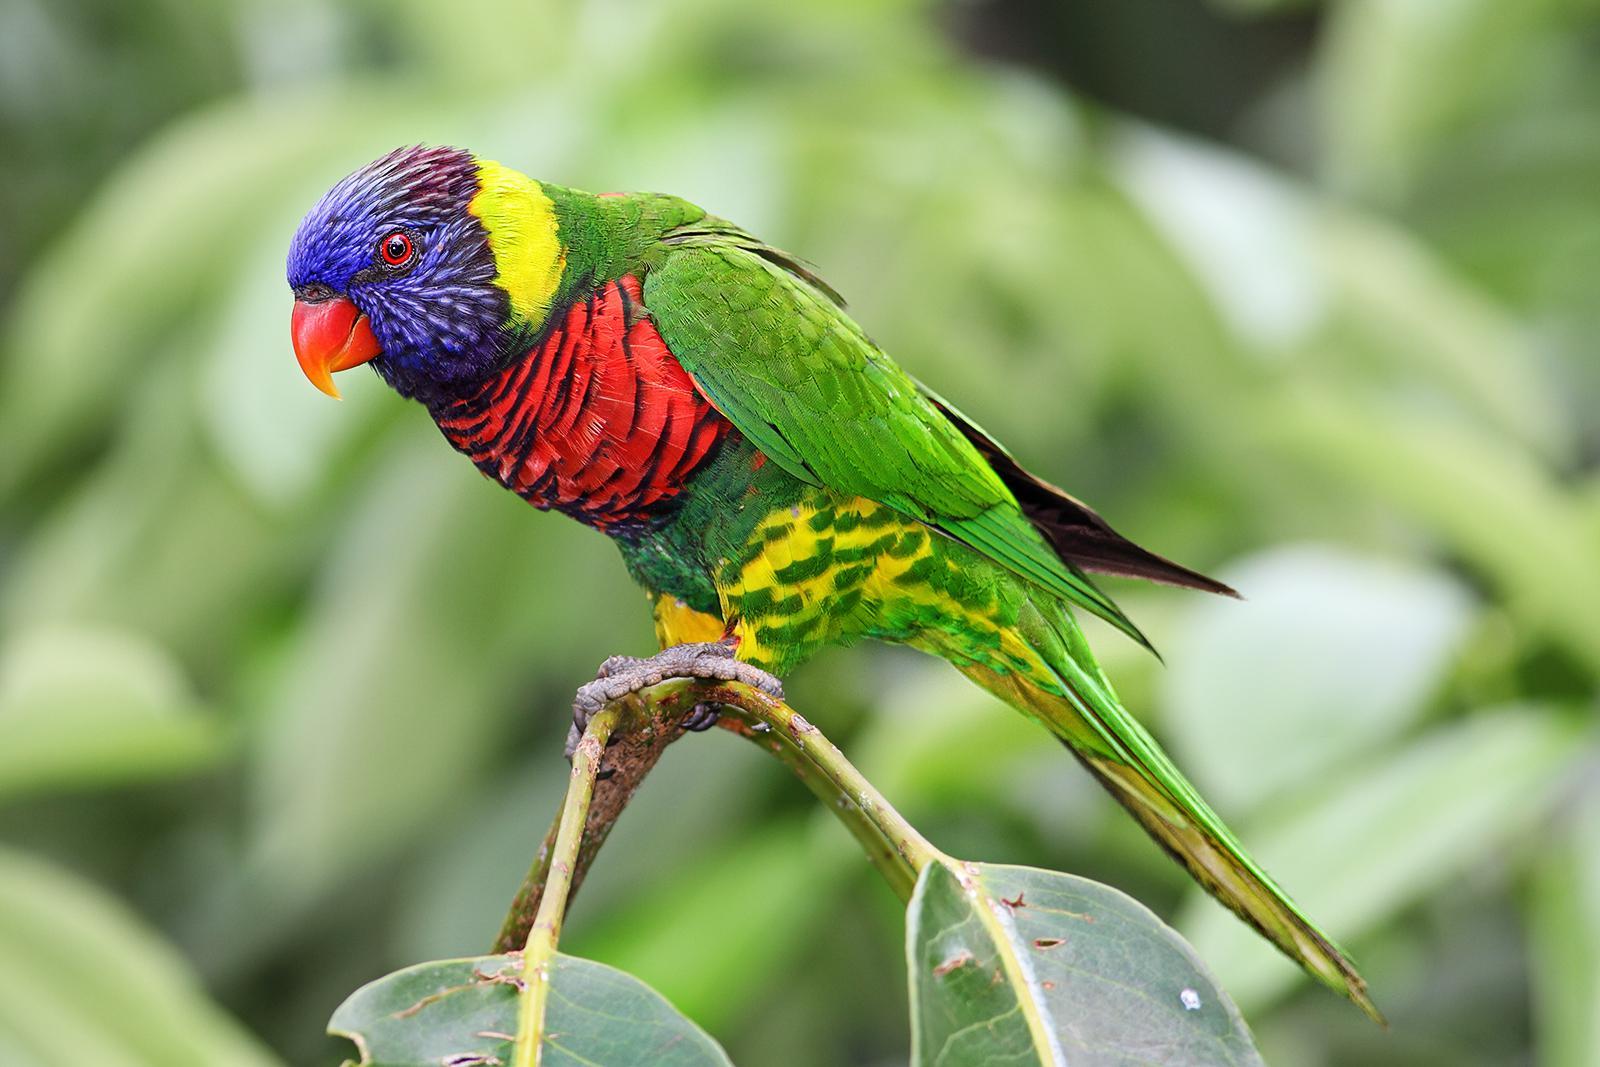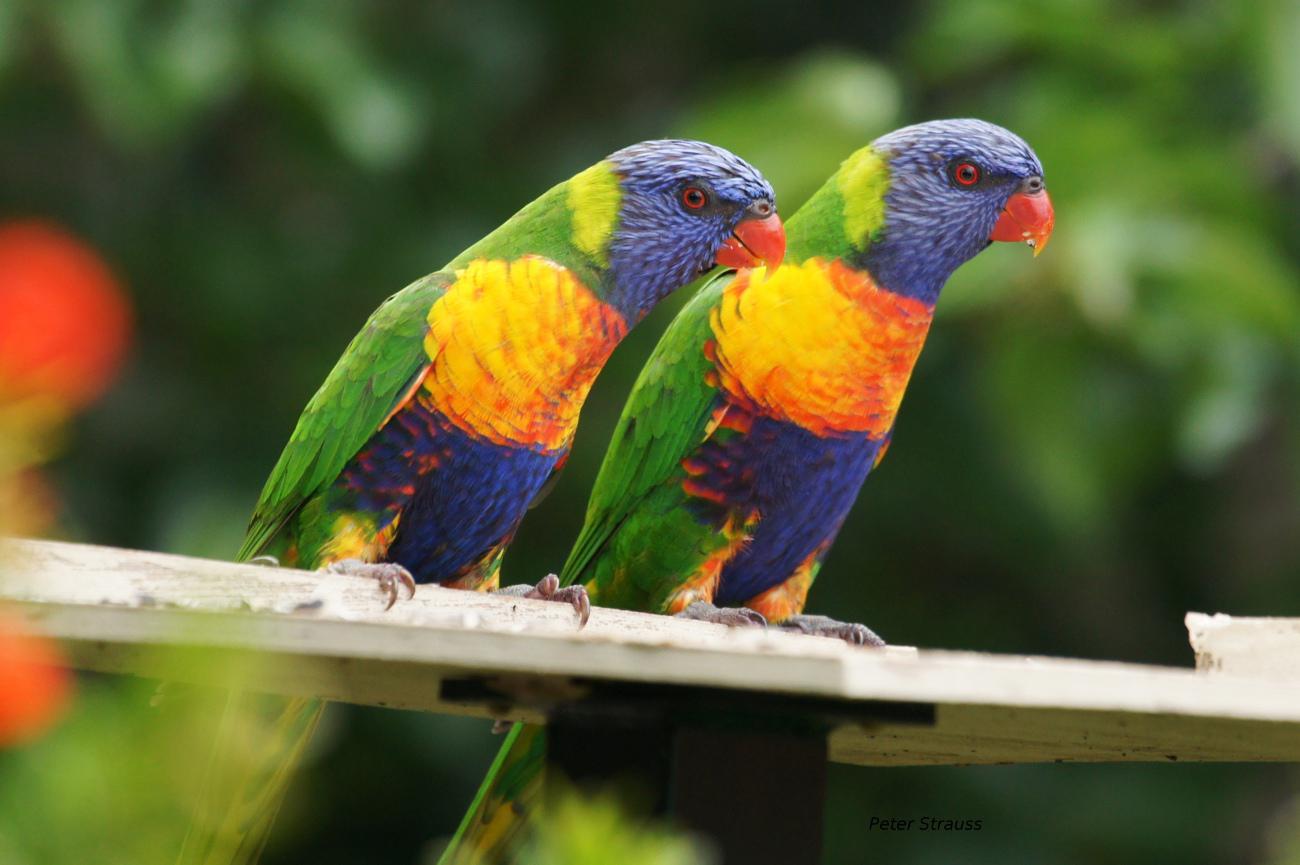The first image is the image on the left, the second image is the image on the right. For the images shown, is this caption "There are exactly two parrots perched on a branch in the right image." true? Answer yes or no. Yes. 